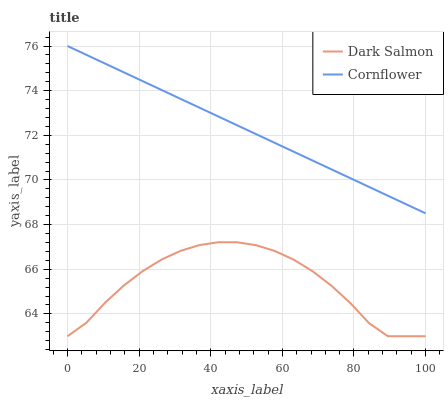Does Dark Salmon have the minimum area under the curve?
Answer yes or no. Yes. Does Cornflower have the maximum area under the curve?
Answer yes or no. Yes. Does Dark Salmon have the maximum area under the curve?
Answer yes or no. No. Is Cornflower the smoothest?
Answer yes or no. Yes. Is Dark Salmon the roughest?
Answer yes or no. Yes. Is Dark Salmon the smoothest?
Answer yes or no. No. Does Dark Salmon have the lowest value?
Answer yes or no. Yes. Does Cornflower have the highest value?
Answer yes or no. Yes. Does Dark Salmon have the highest value?
Answer yes or no. No. Is Dark Salmon less than Cornflower?
Answer yes or no. Yes. Is Cornflower greater than Dark Salmon?
Answer yes or no. Yes. Does Dark Salmon intersect Cornflower?
Answer yes or no. No. 